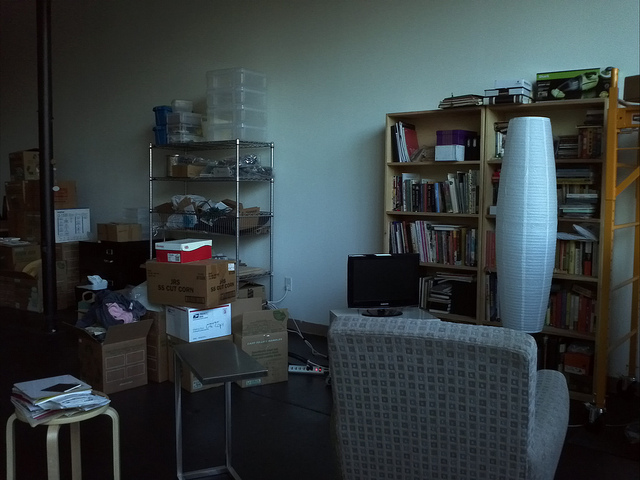<image>What words are displayed? I don't know what words are displayed. It is possible that there are no words in the image. What words are displayed? It is unanswerable what words are displayed in the image. 